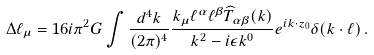<formula> <loc_0><loc_0><loc_500><loc_500>\Delta \ell _ { \mu } = 1 6 i \pi ^ { 2 } G \int \frac { d ^ { 4 } k } { ( 2 \pi ) ^ { 4 } } \frac { k _ { \mu } \ell ^ { \alpha } \ell ^ { \beta } \widehat { T } _ { \alpha \beta } ( k ) } { k ^ { 2 } - i \epsilon k ^ { 0 } } e ^ { i k \cdot z _ { 0 } } \delta ( k \cdot \ell ) \, .</formula> 